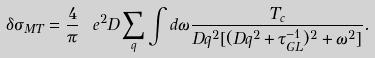Convert formula to latex. <formula><loc_0><loc_0><loc_500><loc_500>\delta \sigma _ { M T } = \frac { 4 } { \pi } \ e ^ { 2 } D \sum _ { q } \int d \omega \frac { T _ { c } } { D q ^ { 2 } [ ( D q ^ { 2 } + \tau ^ { - 1 } _ { G L } ) ^ { 2 } + \omega ^ { 2 } ] } .</formula> 